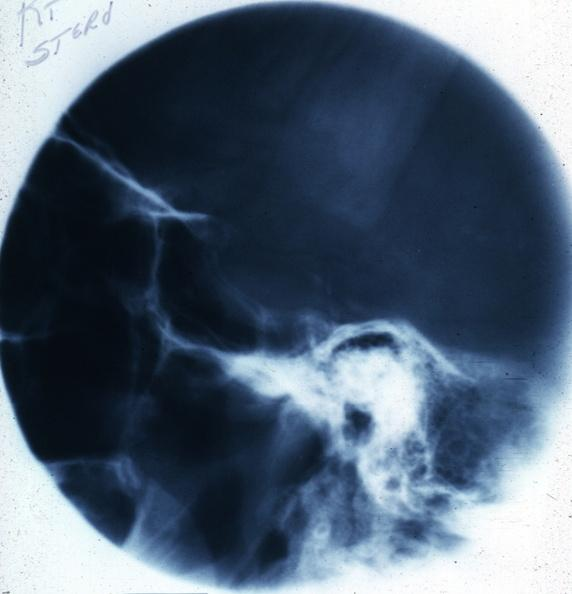does pituitary show x-ray sella?
Answer the question using a single word or phrase. No 